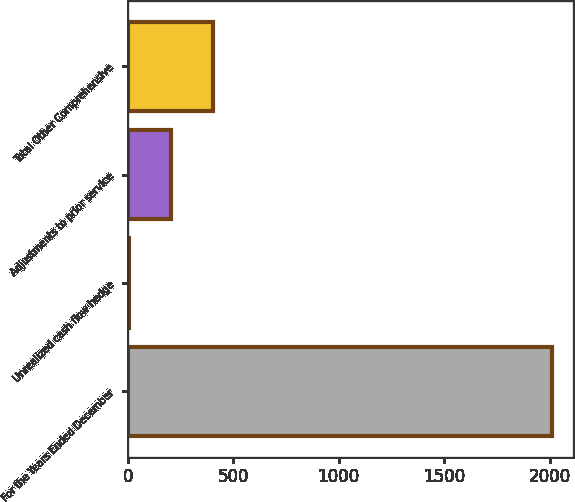Convert chart to OTSL. <chart><loc_0><loc_0><loc_500><loc_500><bar_chart><fcel>For the Years Ended December<fcel>Unrealized cash flow hedge<fcel>Adjustments to prior service<fcel>Total Other Comprehensive<nl><fcel>2012<fcel>4.3<fcel>205.07<fcel>405.84<nl></chart> 